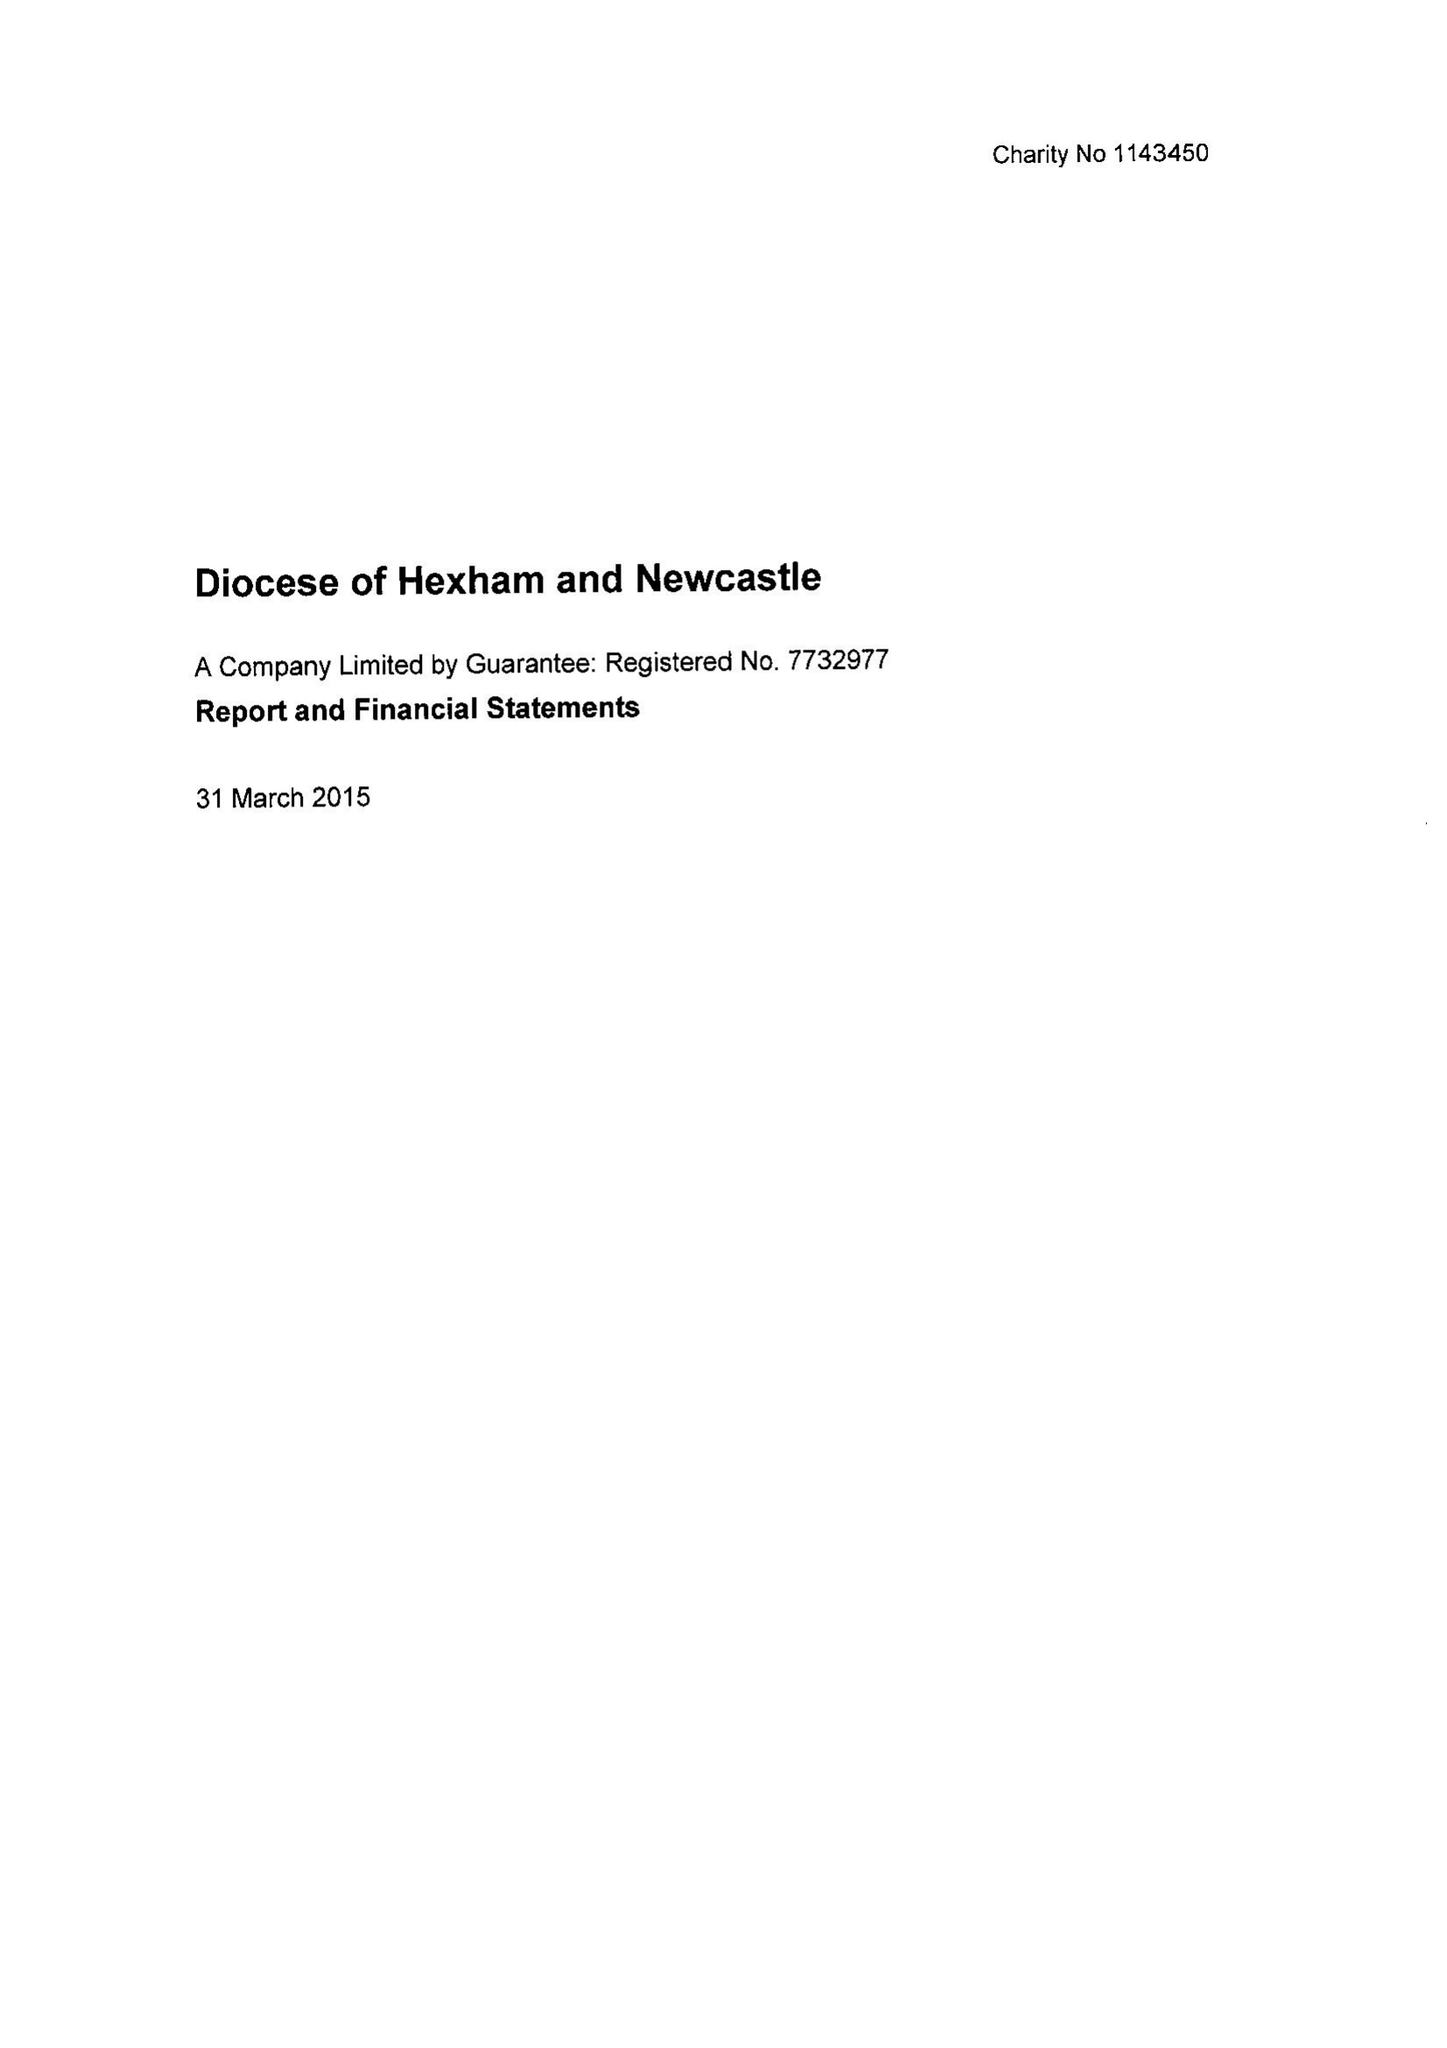What is the value for the charity_name?
Answer the question using a single word or phrase. Diocese Of Hexham and Newcastle 